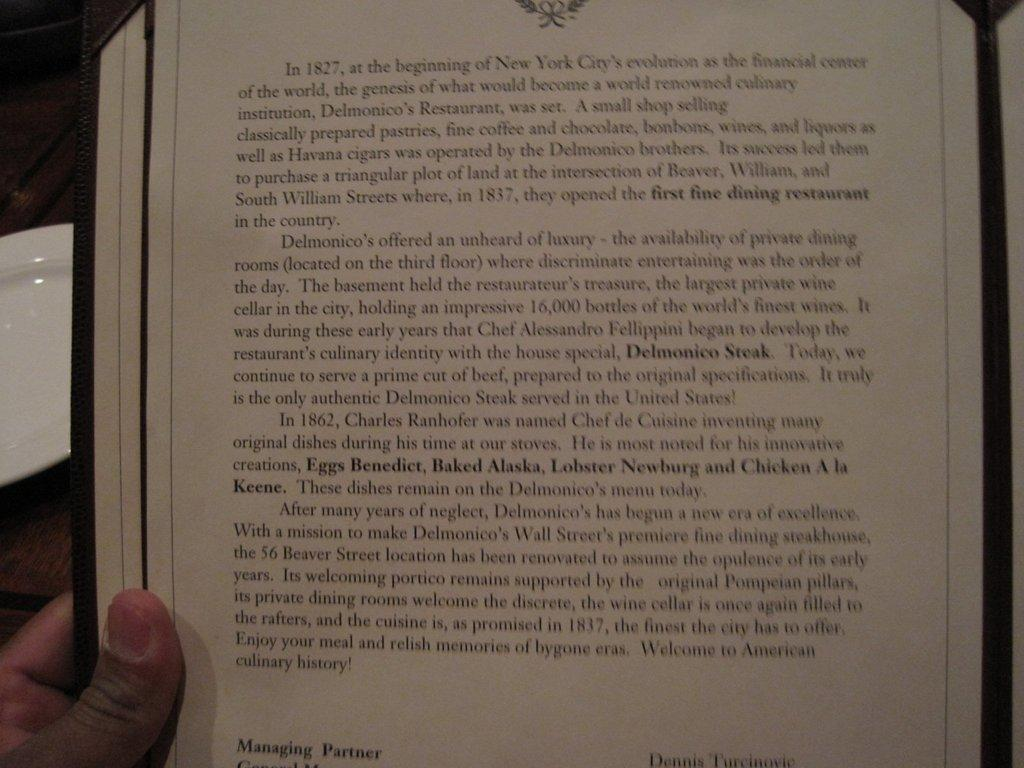<image>
Summarize the visual content of the image. An excerpt from a menu at Delmonico's Restaurant tells the history and background about the place. 